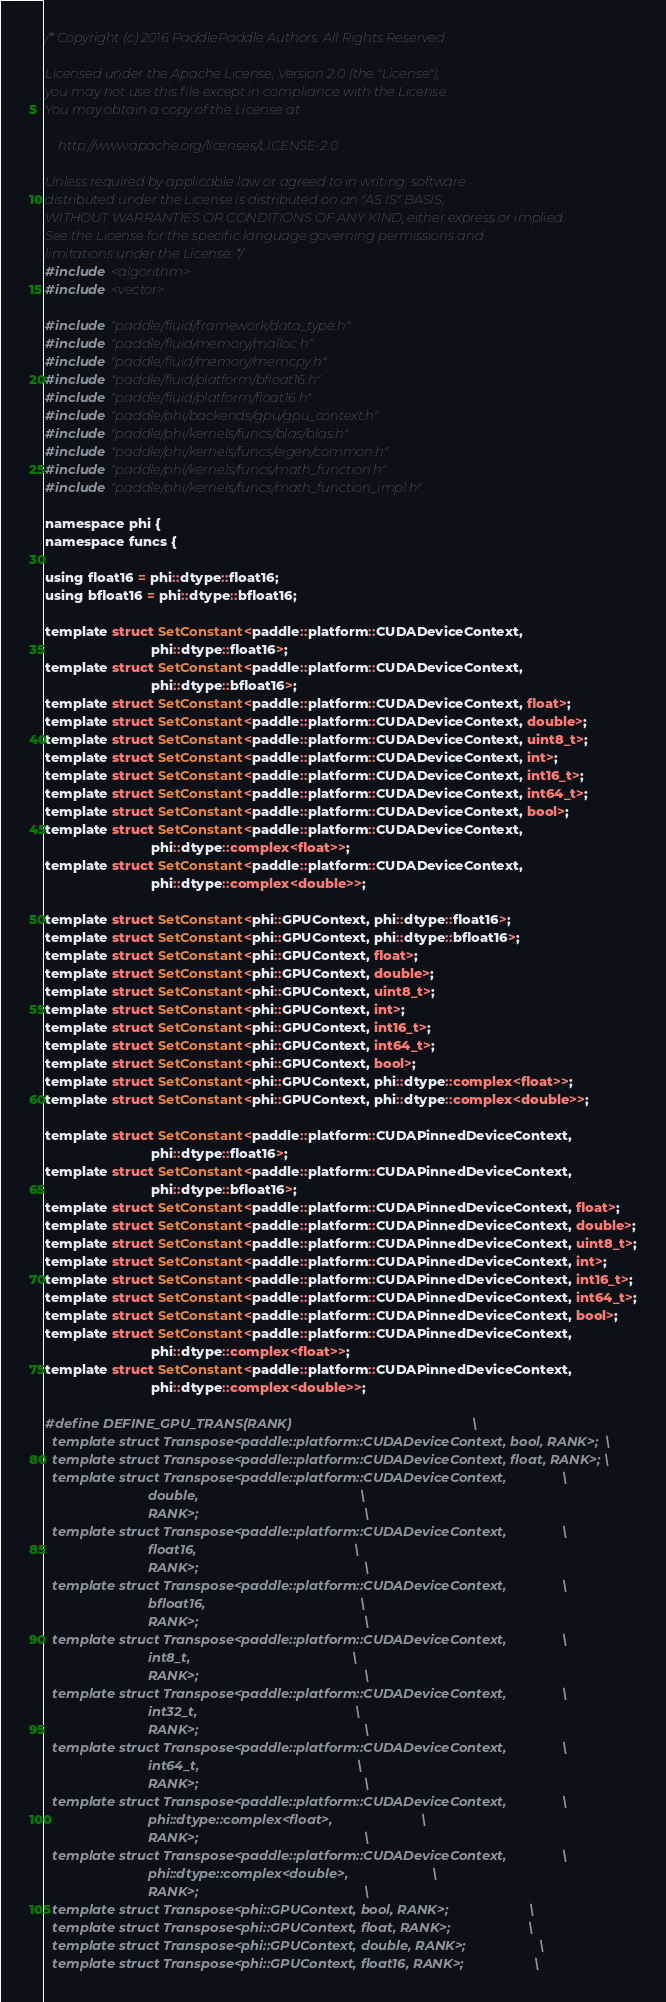Convert code to text. <code><loc_0><loc_0><loc_500><loc_500><_Cuda_>/* Copyright (c) 2016 PaddlePaddle Authors. All Rights Reserved.

Licensed under the Apache License, Version 2.0 (the "License");
you may not use this file except in compliance with the License.
You may obtain a copy of the License at

    http://www.apache.org/licenses/LICENSE-2.0

Unless required by applicable law or agreed to in writing, software
distributed under the License is distributed on an "AS IS" BASIS,
WITHOUT WARRANTIES OR CONDITIONS OF ANY KIND, either express or implied.
See the License for the specific language governing permissions and
limitations under the License. */
#include <algorithm>
#include <vector>

#include "paddle/fluid/framework/data_type.h"
#include "paddle/fluid/memory/malloc.h"
#include "paddle/fluid/memory/memcpy.h"
#include "paddle/fluid/platform/bfloat16.h"
#include "paddle/fluid/platform/float16.h"
#include "paddle/phi/backends/gpu/gpu_context.h"
#include "paddle/phi/kernels/funcs/blas/blas.h"
#include "paddle/phi/kernels/funcs/eigen/common.h"
#include "paddle/phi/kernels/funcs/math_function.h"
#include "paddle/phi/kernels/funcs/math_function_impl.h"

namespace phi {
namespace funcs {

using float16 = phi::dtype::float16;
using bfloat16 = phi::dtype::bfloat16;

template struct SetConstant<paddle::platform::CUDADeviceContext,
                            phi::dtype::float16>;
template struct SetConstant<paddle::platform::CUDADeviceContext,
                            phi::dtype::bfloat16>;
template struct SetConstant<paddle::platform::CUDADeviceContext, float>;
template struct SetConstant<paddle::platform::CUDADeviceContext, double>;
template struct SetConstant<paddle::platform::CUDADeviceContext, uint8_t>;
template struct SetConstant<paddle::platform::CUDADeviceContext, int>;
template struct SetConstant<paddle::platform::CUDADeviceContext, int16_t>;
template struct SetConstant<paddle::platform::CUDADeviceContext, int64_t>;
template struct SetConstant<paddle::platform::CUDADeviceContext, bool>;
template struct SetConstant<paddle::platform::CUDADeviceContext,
                            phi::dtype::complex<float>>;
template struct SetConstant<paddle::platform::CUDADeviceContext,
                            phi::dtype::complex<double>>;

template struct SetConstant<phi::GPUContext, phi::dtype::float16>;
template struct SetConstant<phi::GPUContext, phi::dtype::bfloat16>;
template struct SetConstant<phi::GPUContext, float>;
template struct SetConstant<phi::GPUContext, double>;
template struct SetConstant<phi::GPUContext, uint8_t>;
template struct SetConstant<phi::GPUContext, int>;
template struct SetConstant<phi::GPUContext, int16_t>;
template struct SetConstant<phi::GPUContext, int64_t>;
template struct SetConstant<phi::GPUContext, bool>;
template struct SetConstant<phi::GPUContext, phi::dtype::complex<float>>;
template struct SetConstant<phi::GPUContext, phi::dtype::complex<double>>;

template struct SetConstant<paddle::platform::CUDAPinnedDeviceContext,
                            phi::dtype::float16>;
template struct SetConstant<paddle::platform::CUDAPinnedDeviceContext,
                            phi::dtype::bfloat16>;
template struct SetConstant<paddle::platform::CUDAPinnedDeviceContext, float>;
template struct SetConstant<paddle::platform::CUDAPinnedDeviceContext, double>;
template struct SetConstant<paddle::platform::CUDAPinnedDeviceContext, uint8_t>;
template struct SetConstant<paddle::platform::CUDAPinnedDeviceContext, int>;
template struct SetConstant<paddle::platform::CUDAPinnedDeviceContext, int16_t>;
template struct SetConstant<paddle::platform::CUDAPinnedDeviceContext, int64_t>;
template struct SetConstant<paddle::platform::CUDAPinnedDeviceContext, bool>;
template struct SetConstant<paddle::platform::CUDAPinnedDeviceContext,
                            phi::dtype::complex<float>>;
template struct SetConstant<paddle::platform::CUDAPinnedDeviceContext,
                            phi::dtype::complex<double>>;

#define DEFINE_GPU_TRANS(RANK)                                                 \
  template struct Transpose<paddle::platform::CUDADeviceContext, bool, RANK>;  \
  template struct Transpose<paddle::platform::CUDADeviceContext, float, RANK>; \
  template struct Transpose<paddle::platform::CUDADeviceContext,               \
                            double,                                            \
                            RANK>;                                             \
  template struct Transpose<paddle::platform::CUDADeviceContext,               \
                            float16,                                           \
                            RANK>;                                             \
  template struct Transpose<paddle::platform::CUDADeviceContext,               \
                            bfloat16,                                          \
                            RANK>;                                             \
  template struct Transpose<paddle::platform::CUDADeviceContext,               \
                            int8_t,                                            \
                            RANK>;                                             \
  template struct Transpose<paddle::platform::CUDADeviceContext,               \
                            int32_t,                                           \
                            RANK>;                                             \
  template struct Transpose<paddle::platform::CUDADeviceContext,               \
                            int64_t,                                           \
                            RANK>;                                             \
  template struct Transpose<paddle::platform::CUDADeviceContext,               \
                            phi::dtype::complex<float>,                        \
                            RANK>;                                             \
  template struct Transpose<paddle::platform::CUDADeviceContext,               \
                            phi::dtype::complex<double>,                       \
                            RANK>;                                             \
  template struct Transpose<phi::GPUContext, bool, RANK>;                      \
  template struct Transpose<phi::GPUContext, float, RANK>;                     \
  template struct Transpose<phi::GPUContext, double, RANK>;                    \
  template struct Transpose<phi::GPUContext, float16, RANK>;                   \</code> 